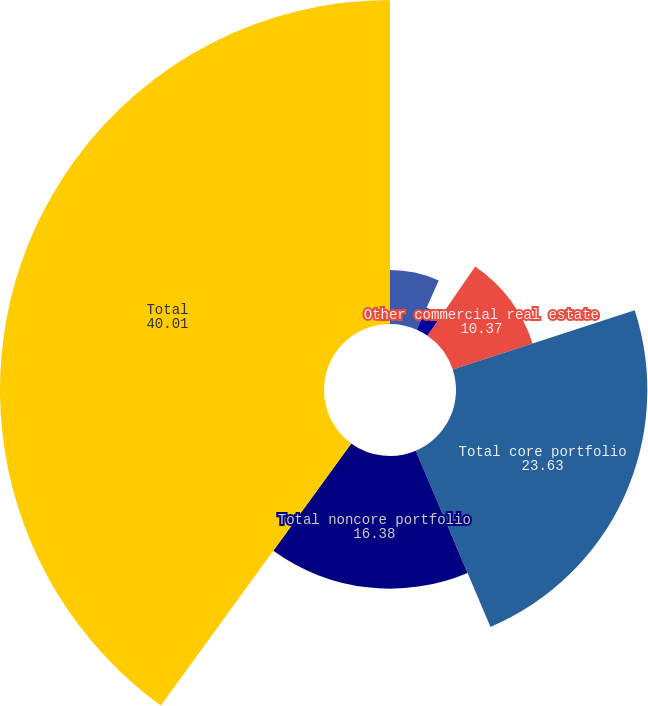<chart> <loc_0><loc_0><loc_500><loc_500><pie_chart><fcel>Office<fcel>Industrial and warehouse<fcel>Other commercial real estate<fcel>Total core portfolio<fcel>Total noncore portfolio<fcel>Total<nl><fcel>6.66%<fcel>2.96%<fcel>10.37%<fcel>23.63%<fcel>16.38%<fcel>40.01%<nl></chart> 